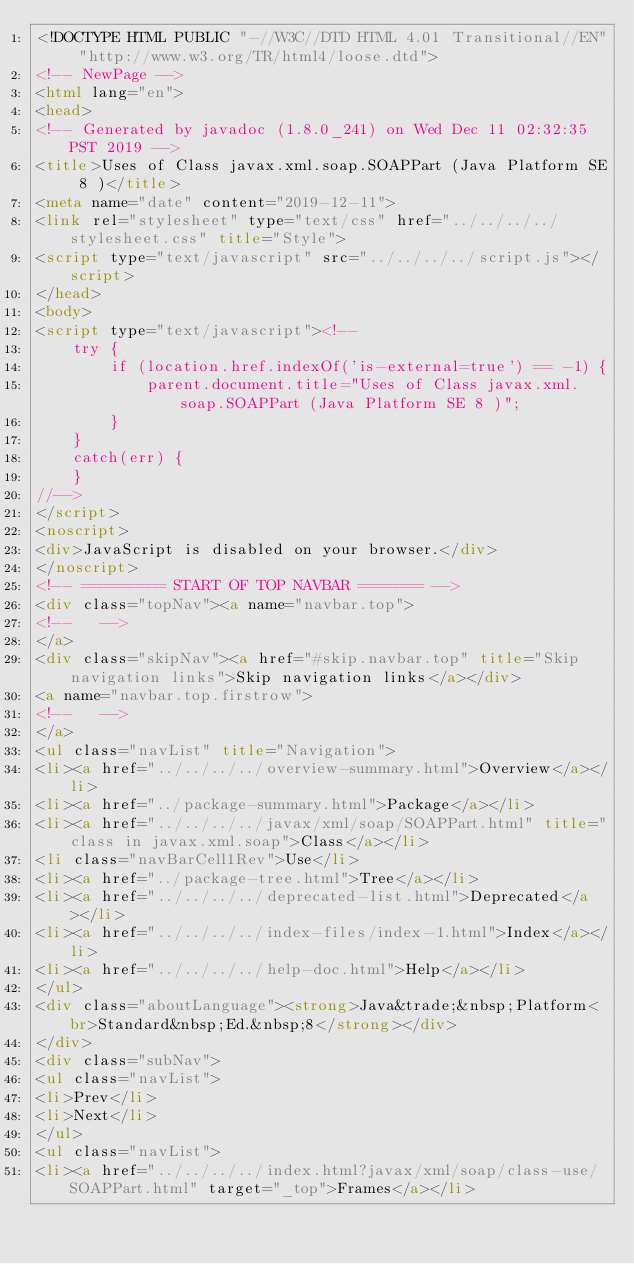<code> <loc_0><loc_0><loc_500><loc_500><_HTML_><!DOCTYPE HTML PUBLIC "-//W3C//DTD HTML 4.01 Transitional//EN" "http://www.w3.org/TR/html4/loose.dtd">
<!-- NewPage -->
<html lang="en">
<head>
<!-- Generated by javadoc (1.8.0_241) on Wed Dec 11 02:32:35 PST 2019 -->
<title>Uses of Class javax.xml.soap.SOAPPart (Java Platform SE 8 )</title>
<meta name="date" content="2019-12-11">
<link rel="stylesheet" type="text/css" href="../../../../stylesheet.css" title="Style">
<script type="text/javascript" src="../../../../script.js"></script>
</head>
<body>
<script type="text/javascript"><!--
    try {
        if (location.href.indexOf('is-external=true') == -1) {
            parent.document.title="Uses of Class javax.xml.soap.SOAPPart (Java Platform SE 8 )";
        }
    }
    catch(err) {
    }
//-->
</script>
<noscript>
<div>JavaScript is disabled on your browser.</div>
</noscript>
<!-- ========= START OF TOP NAVBAR ======= -->
<div class="topNav"><a name="navbar.top">
<!--   -->
</a>
<div class="skipNav"><a href="#skip.navbar.top" title="Skip navigation links">Skip navigation links</a></div>
<a name="navbar.top.firstrow">
<!--   -->
</a>
<ul class="navList" title="Navigation">
<li><a href="../../../../overview-summary.html">Overview</a></li>
<li><a href="../package-summary.html">Package</a></li>
<li><a href="../../../../javax/xml/soap/SOAPPart.html" title="class in javax.xml.soap">Class</a></li>
<li class="navBarCell1Rev">Use</li>
<li><a href="../package-tree.html">Tree</a></li>
<li><a href="../../../../deprecated-list.html">Deprecated</a></li>
<li><a href="../../../../index-files/index-1.html">Index</a></li>
<li><a href="../../../../help-doc.html">Help</a></li>
</ul>
<div class="aboutLanguage"><strong>Java&trade;&nbsp;Platform<br>Standard&nbsp;Ed.&nbsp;8</strong></div>
</div>
<div class="subNav">
<ul class="navList">
<li>Prev</li>
<li>Next</li>
</ul>
<ul class="navList">
<li><a href="../../../../index.html?javax/xml/soap/class-use/SOAPPart.html" target="_top">Frames</a></li></code> 